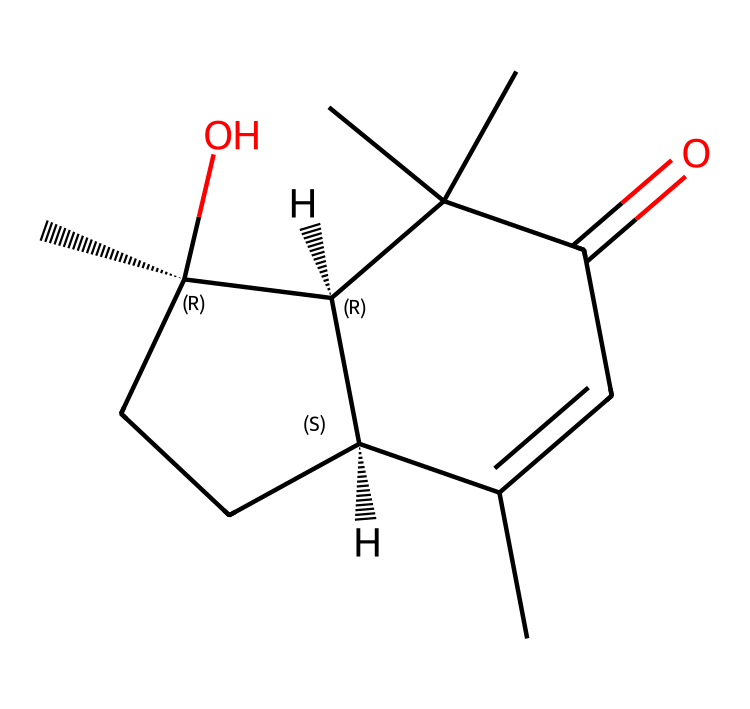what is the main functional group in this structure? The chemical structure contains a carbonyl group (C=O) that indicates a ketone functional group, which is identified by the presence of the carbonyl carbon bonded to two other carbon atoms.
Answer: ketone how many rings are present in this chemical? The structure shows two interconnected rings, as indicated by the cyclic arrangement of carbon atoms in the SMILES representation.
Answer: two what type of flavor profile does this chemical contribute to vermouth? This chemical is likely to contribute herbal and sweet flavor notes to vermouth due to its complex structure and specific functional groups that enhance these characteristics.
Answer: herbal and sweet which part of the chemical indicates its sweetness? The presence of the hydroxyl group (-OH) along with its structure enhances sweetness, typically associated with sugars and alcohols, which is indicative of flavor profiles in fortified wines like vermouth.
Answer: hydroxyl group what is the molecular formula derived from the SMILES provided? By interpreting the SMILES string, the molecular formula can be constructed from the counts of each atom present, giving us C15H22O3.
Answer: C15H22O3 how many chiral centers exist in this molecule? The structure contains two chiral centers as indicated by the stereochemistry specified in the SMILES notation, which includes symbols “@” indicating the presence of chiral centers in the carbon backbone.
Answer: two 